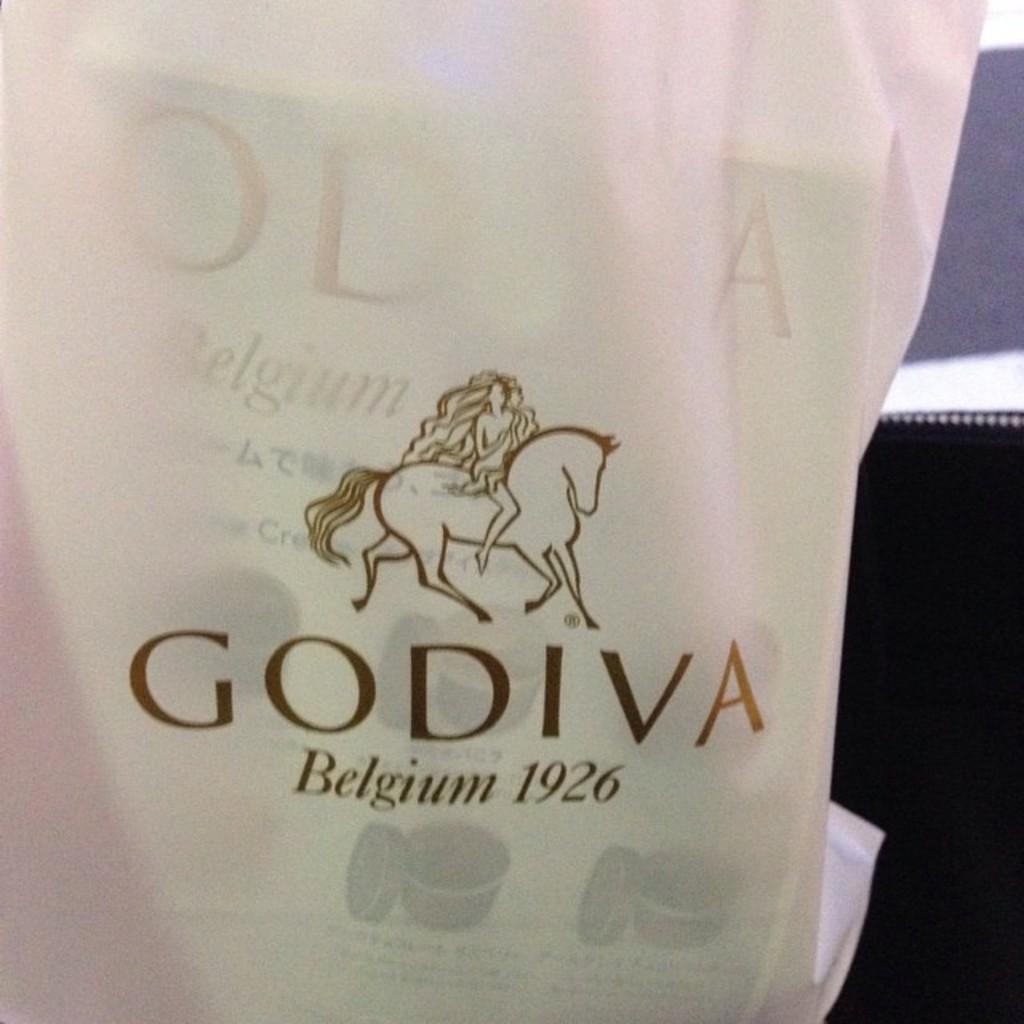Describe this image in one or two sentences. In this picture we can see a bag here, we can see a book in the bag, there is some text and symbol of horse on the bag. 